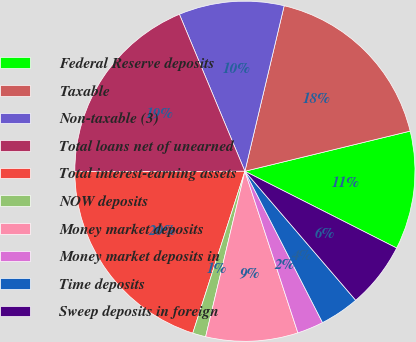Convert chart to OTSL. <chart><loc_0><loc_0><loc_500><loc_500><pie_chart><fcel>Federal Reserve deposits<fcel>Taxable<fcel>Non-taxable (3)<fcel>Total loans net of unearned<fcel>Total interest-earning assets<fcel>NOW deposits<fcel>Money market deposits<fcel>Money market deposits in<fcel>Time deposits<fcel>Sweep deposits in foreign<nl><fcel>11.25%<fcel>17.5%<fcel>10.0%<fcel>18.75%<fcel>20.0%<fcel>1.25%<fcel>8.75%<fcel>2.5%<fcel>3.75%<fcel>6.25%<nl></chart> 